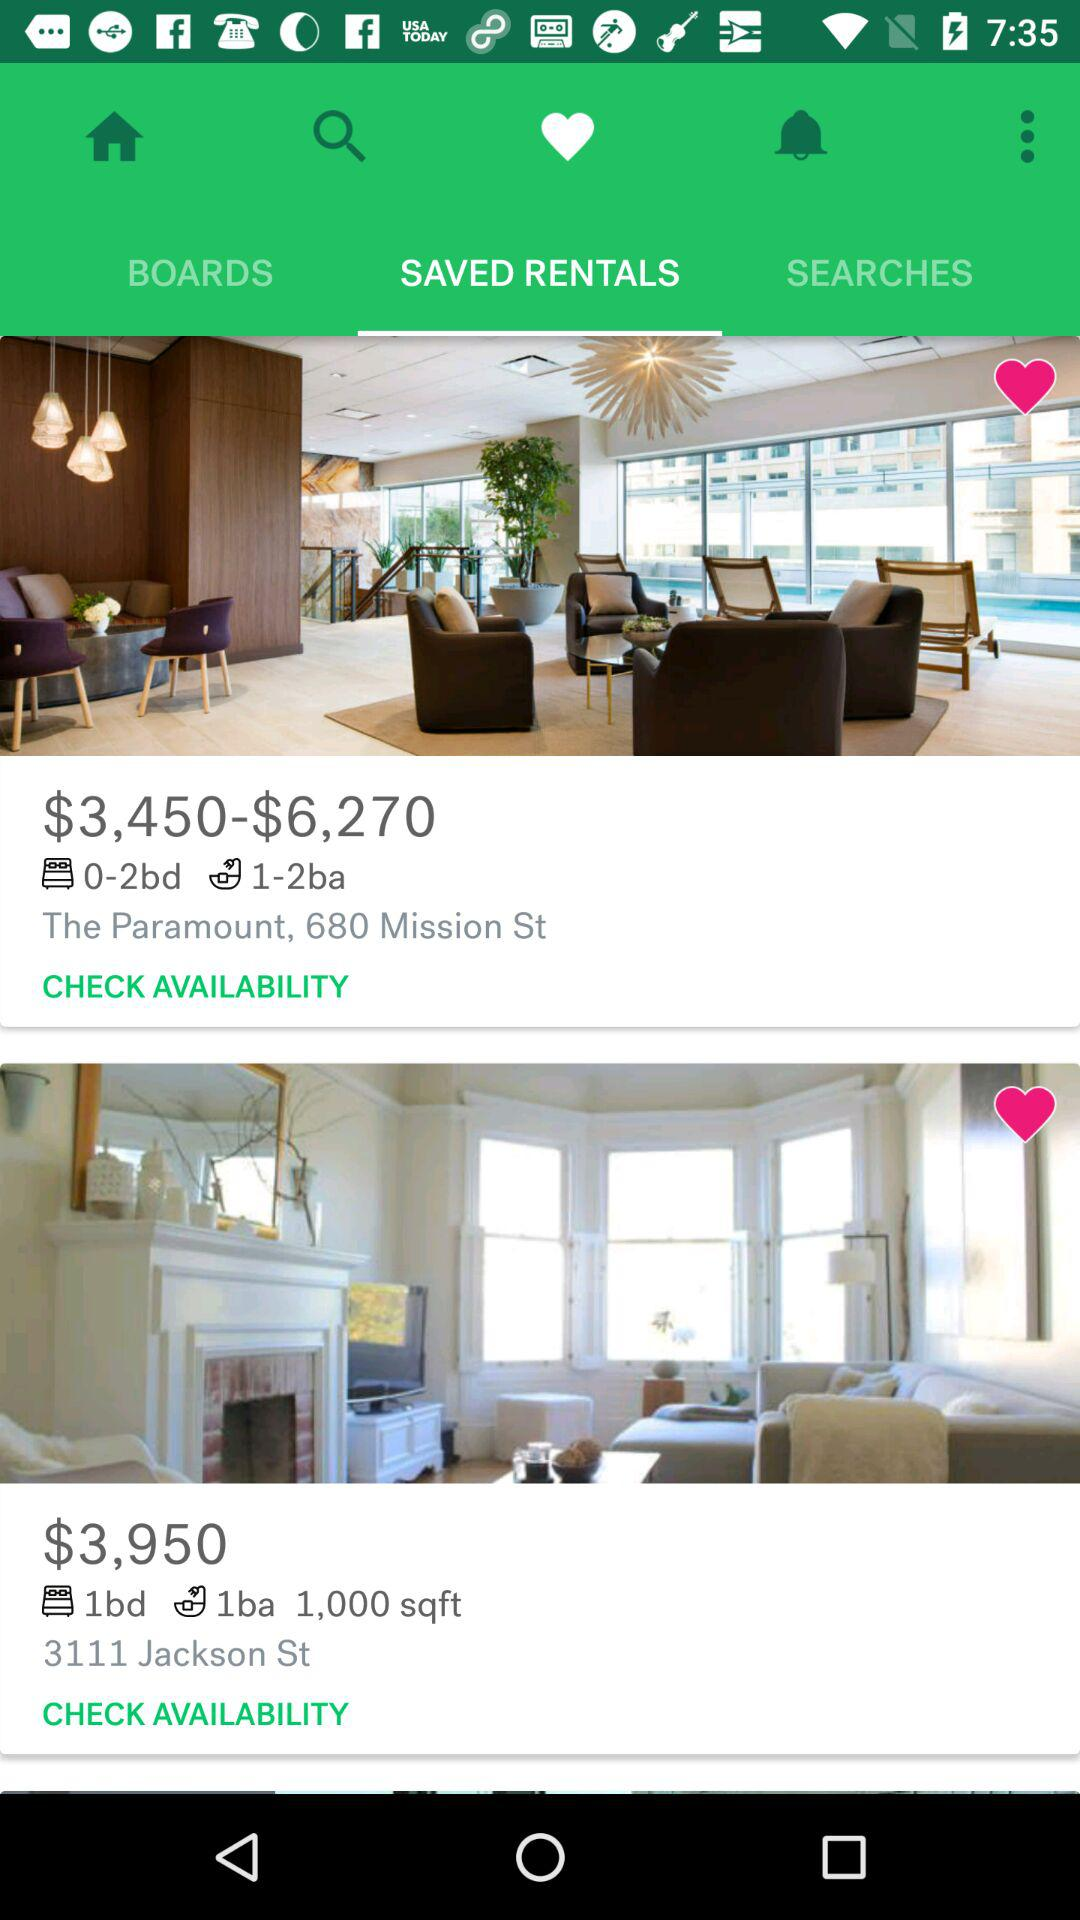Which tab is selected? The selected tabs are "Favorite" and "SAVED RENTALS". 